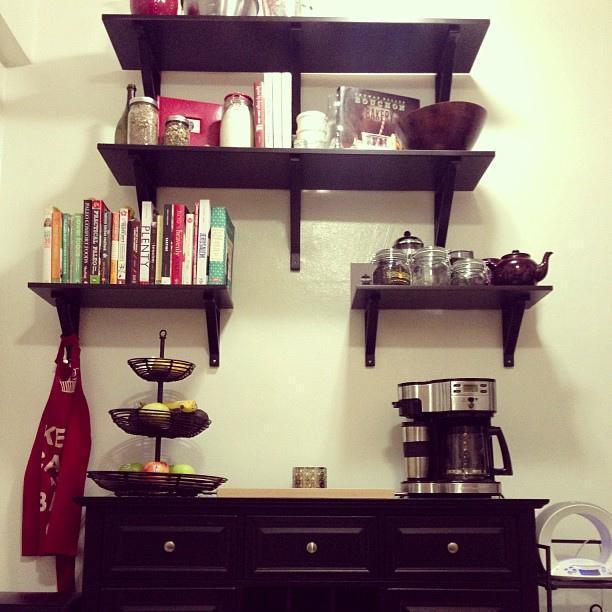How many bowls are there?
Give a very brief answer. 2. How many people have black shirts on?
Give a very brief answer. 0. 